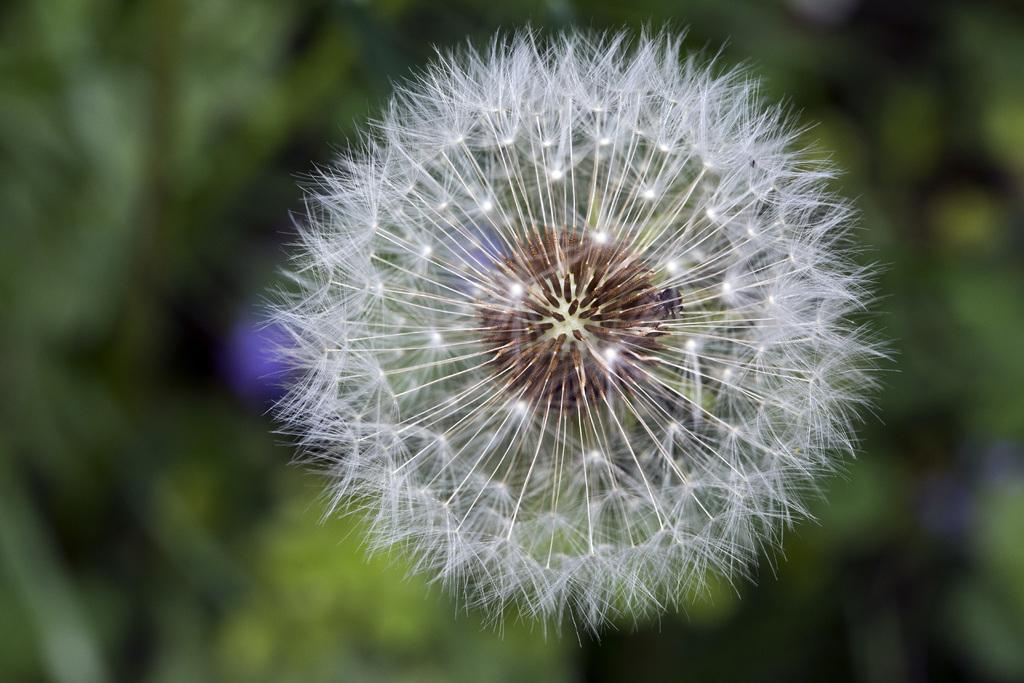What type of plant is in the foreground of the image? There is a dandelion plant in the foreground of the image. What can be seen in the background of the image? There is greenery in the background of the image. What type of rock is visible in the image? There is no rock visible in the image; it features a dandelion plant in the foreground and greenery in the background. 